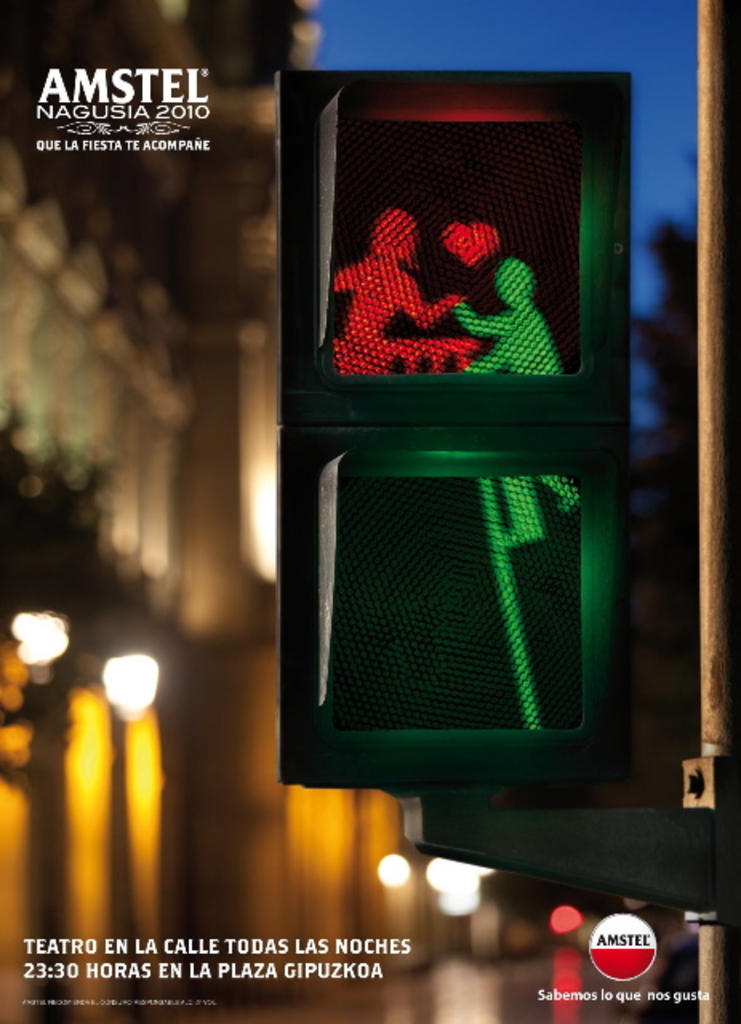What does the depiction of people in the traffic light signify in this advertisement? The depiction of people inside the traffic light creatively symbolizes the idea of 'stop and enjoy the moment,' fitting with the theme of celebration and nightlife that the Amstel Nagusia festival encourages. 